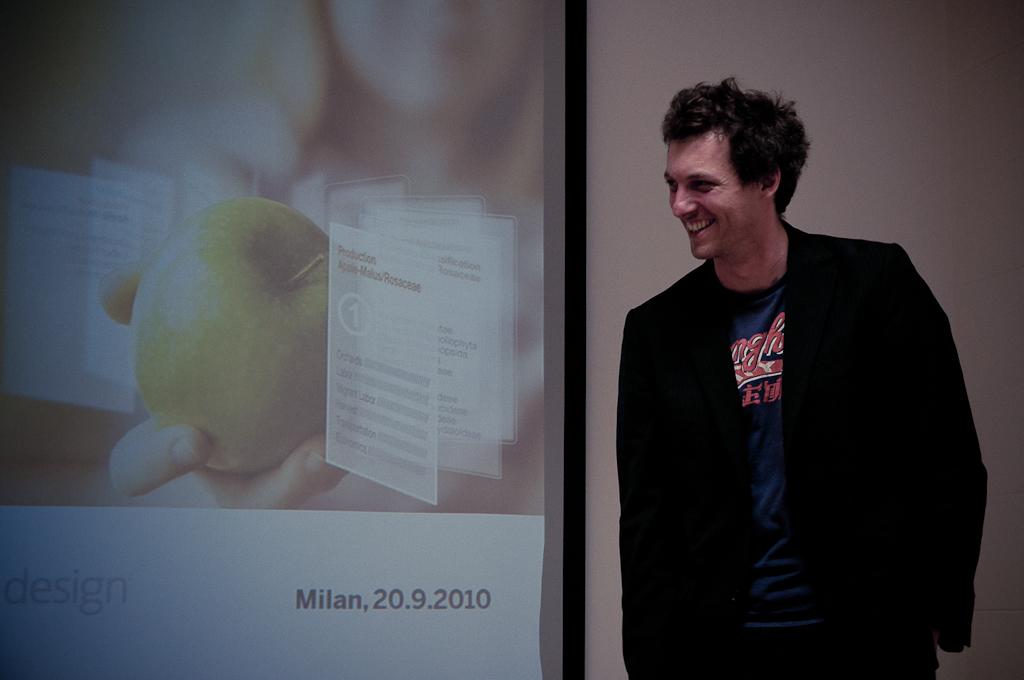Where is this presentation being given?
Your response must be concise. Milan. What is the date of this presentation?
Your answer should be compact. 20.9.2010. 